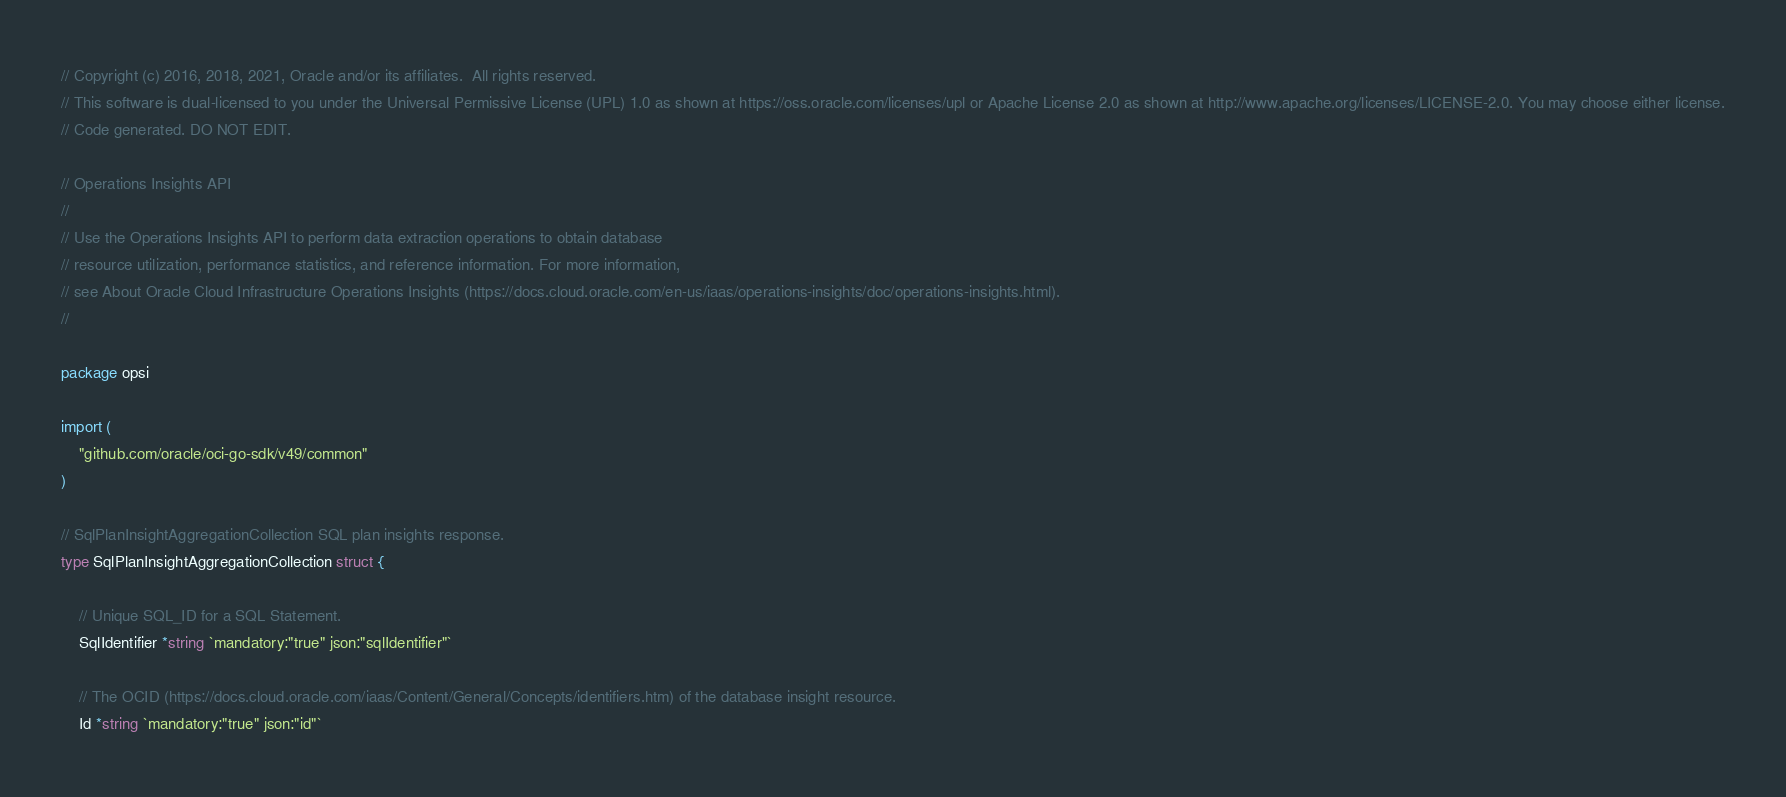<code> <loc_0><loc_0><loc_500><loc_500><_Go_>// Copyright (c) 2016, 2018, 2021, Oracle and/or its affiliates.  All rights reserved.
// This software is dual-licensed to you under the Universal Permissive License (UPL) 1.0 as shown at https://oss.oracle.com/licenses/upl or Apache License 2.0 as shown at http://www.apache.org/licenses/LICENSE-2.0. You may choose either license.
// Code generated. DO NOT EDIT.

// Operations Insights API
//
// Use the Operations Insights API to perform data extraction operations to obtain database
// resource utilization, performance statistics, and reference information. For more information,
// see About Oracle Cloud Infrastructure Operations Insights (https://docs.cloud.oracle.com/en-us/iaas/operations-insights/doc/operations-insights.html).
//

package opsi

import (
	"github.com/oracle/oci-go-sdk/v49/common"
)

// SqlPlanInsightAggregationCollection SQL plan insights response.
type SqlPlanInsightAggregationCollection struct {

	// Unique SQL_ID for a SQL Statement.
	SqlIdentifier *string `mandatory:"true" json:"sqlIdentifier"`

	// The OCID (https://docs.cloud.oracle.com/iaas/Content/General/Concepts/identifiers.htm) of the database insight resource.
	Id *string `mandatory:"true" json:"id"`
</code> 